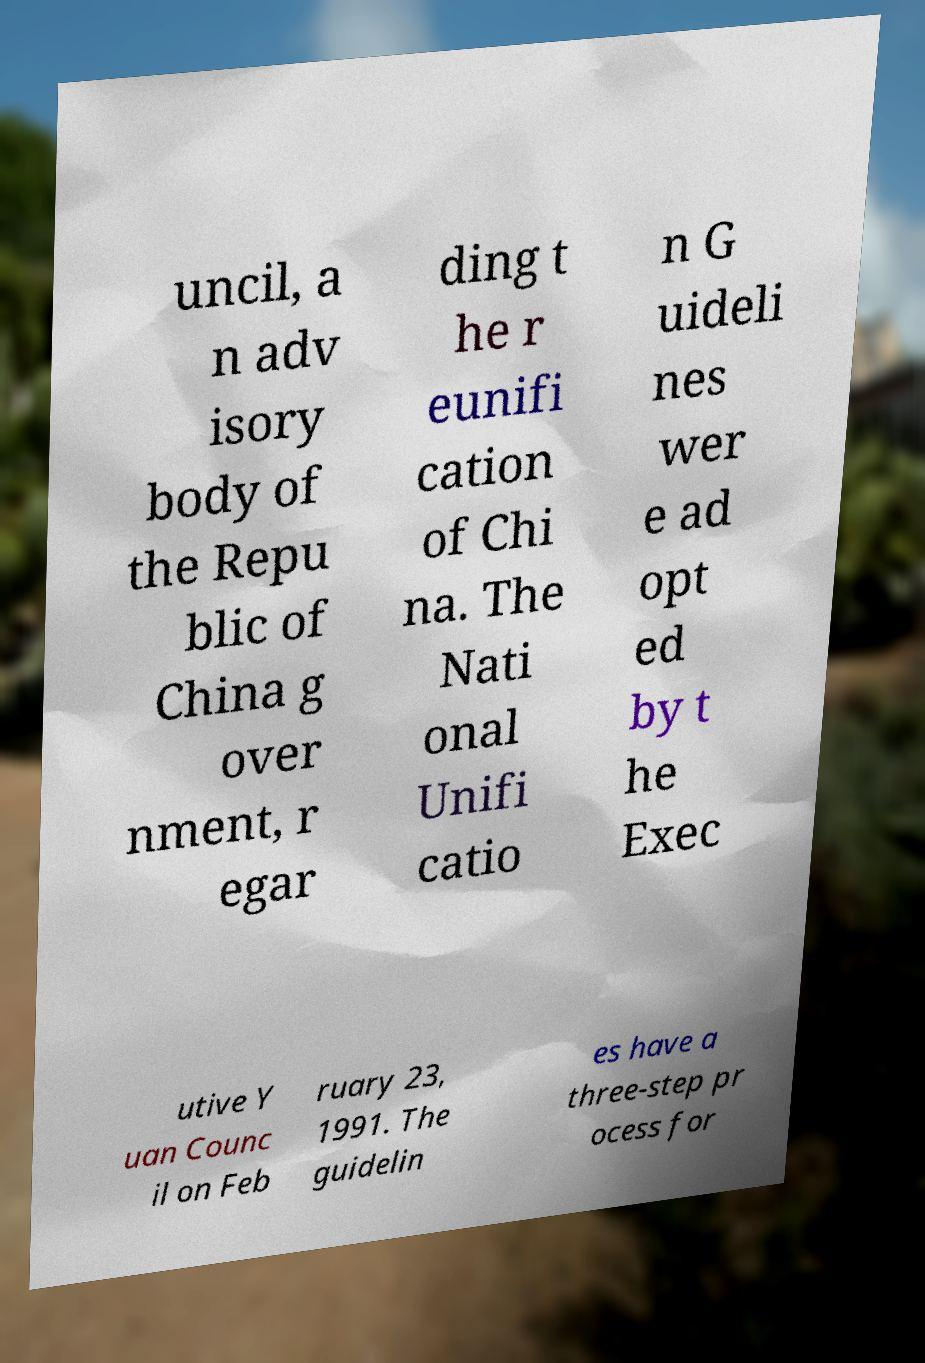Could you extract and type out the text from this image? uncil, a n adv isory body of the Repu blic of China g over nment, r egar ding t he r eunifi cation of Chi na. The Nati onal Unifi catio n G uideli nes wer e ad opt ed by t he Exec utive Y uan Counc il on Feb ruary 23, 1991. The guidelin es have a three-step pr ocess for 